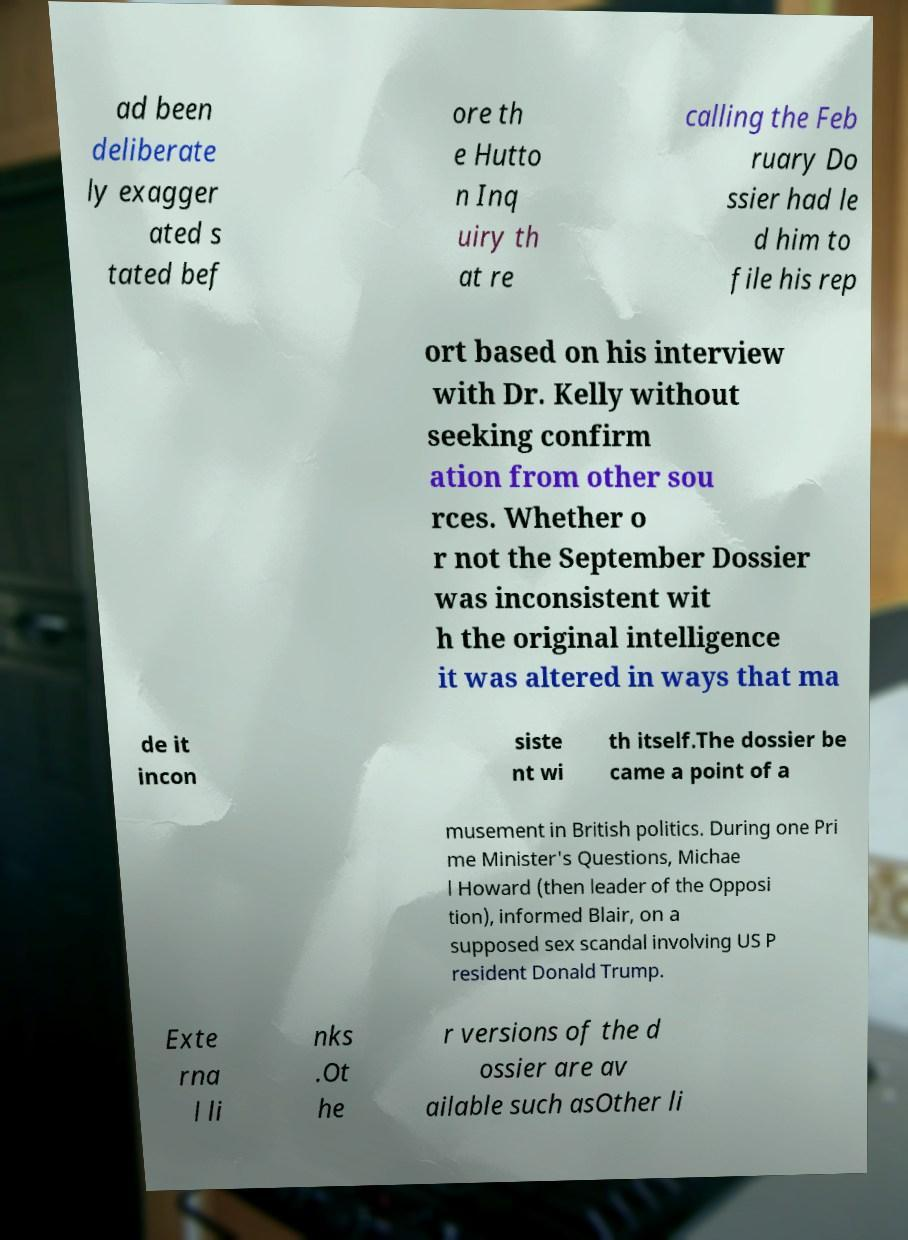Please identify and transcribe the text found in this image. ad been deliberate ly exagger ated s tated bef ore th e Hutto n Inq uiry th at re calling the Feb ruary Do ssier had le d him to file his rep ort based on his interview with Dr. Kelly without seeking confirm ation from other sou rces. Whether o r not the September Dossier was inconsistent wit h the original intelligence it was altered in ways that ma de it incon siste nt wi th itself.The dossier be came a point of a musement in British politics. During one Pri me Minister's Questions, Michae l Howard (then leader of the Opposi tion), informed Blair, on a supposed sex scandal involving US P resident Donald Trump. Exte rna l li nks .Ot he r versions of the d ossier are av ailable such asOther li 